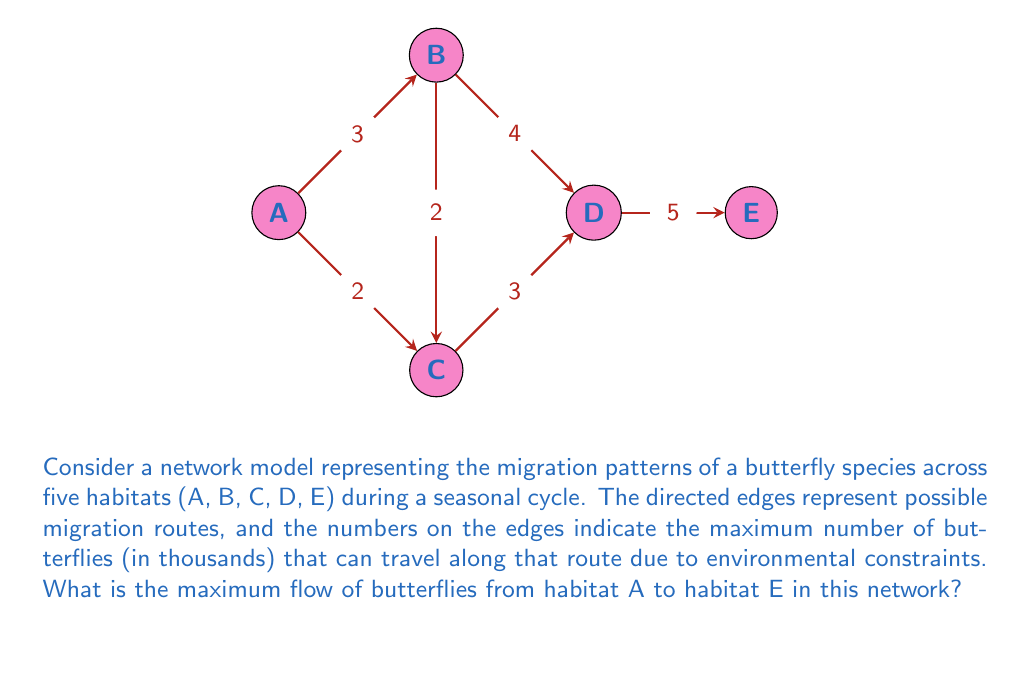Help me with this question. To solve this maximum flow problem, we can use the Ford-Fulkerson algorithm:

1) Initialize flow on all edges to 0.

2) Find an augmenting path from A to E:
   Path 1: A → B → D → E (min capacity = 3)
   Update flows: 
   A → B: 3, B → D: 3, D → E: 3
   Residual graph updated.

3) Find another augmenting path:
   Path 2: A → C → D → E (min capacity = 2)
   Update flows:
   A → C: 2, C → D: 2, D → E: 5
   Residual graph updated.

4) No more augmenting paths exist.

5) Calculate total flow:
   Flow out of A = Flow into E = 3 + 2 = 5

The maximum flow is achieved when:
- 3 thousand butterflies migrate A → B → D → E
- 2 thousand butterflies migrate A → C → D → E

We can verify that this satisfies the capacity constraints:
- A → B: 3 ≤ 3
- A → C: 2 ≤ 2
- B → D: 3 ≤ 4
- C → D: 2 ≤ 3
- D → E: 5 ≤ 5

The flow conservation property is also satisfied at nodes B, C, and D.

Therefore, the maximum flow of butterflies from habitat A to habitat E is 5 thousand.
Answer: 5 thousand butterflies 